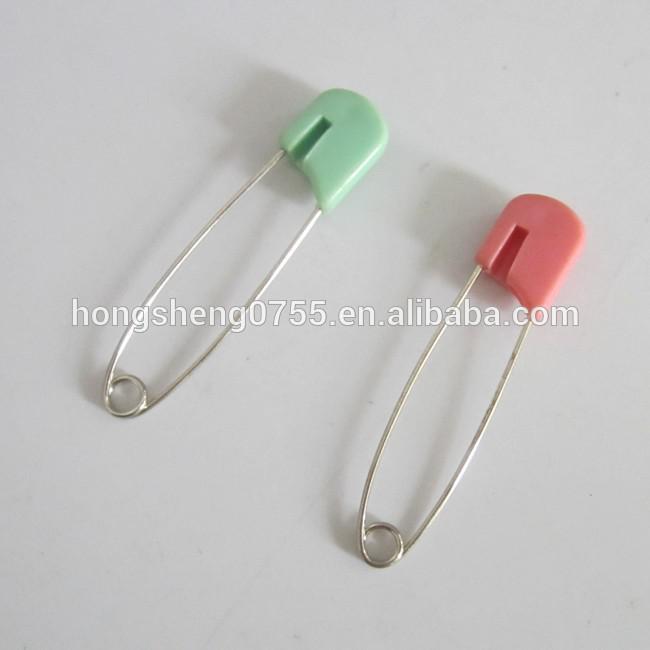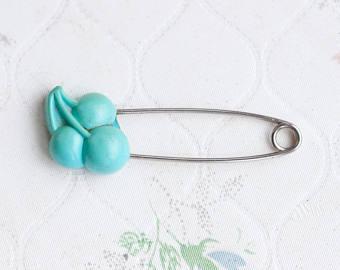The first image is the image on the left, the second image is the image on the right. Evaluate the accuracy of this statement regarding the images: "In at least one image the clip is not silver at all.". Is it true? Answer yes or no. No. 